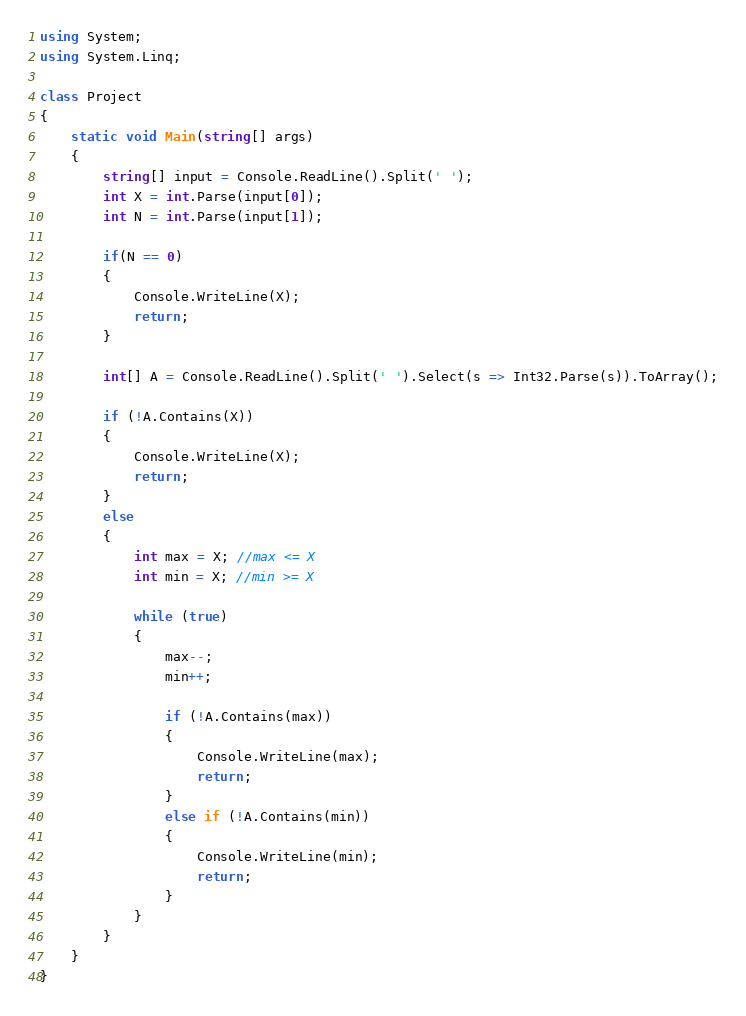Convert code to text. <code><loc_0><loc_0><loc_500><loc_500><_C#_>using System;
using System.Linq;

class Project
{
    static void Main(string[] args)
    {
        string[] input = Console.ReadLine().Split(' ');
        int X = int.Parse(input[0]);
        int N = int.Parse(input[1]);

        if(N == 0)
        {
            Console.WriteLine(X);
            return;
        }

        int[] A = Console.ReadLine().Split(' ').Select(s => Int32.Parse(s)).ToArray();

        if (!A.Contains(X))
        {
            Console.WriteLine(X);
            return;
        }
        else
        {
            int max = X; //max <= X
            int min = X; //min >= X

            while (true)
            {
                max--;
                min++;

                if (!A.Contains(max))
                {
                    Console.WriteLine(max);
                    return;
                }
                else if (!A.Contains(min))
                {
                    Console.WriteLine(min);
                    return;
                }
            }
        }
    }
}</code> 